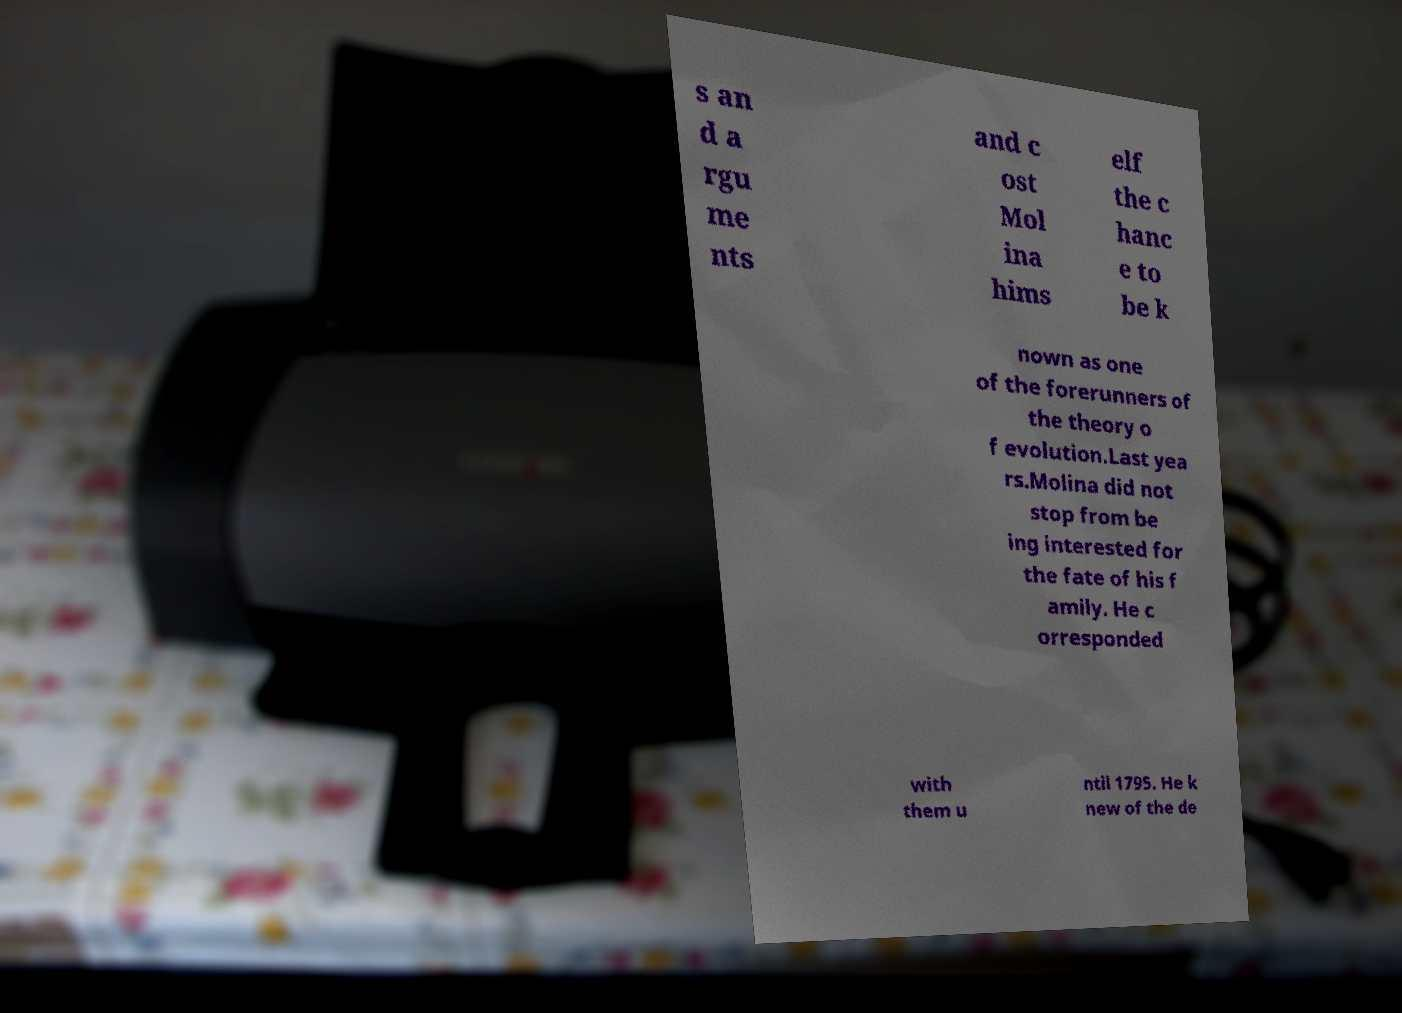I need the written content from this picture converted into text. Can you do that? s an d a rgu me nts and c ost Mol ina hims elf the c hanc e to be k nown as one of the forerunners of the theory o f evolution.Last yea rs.Molina did not stop from be ing interested for the fate of his f amily. He c orresponded with them u ntil 1795. He k new of the de 